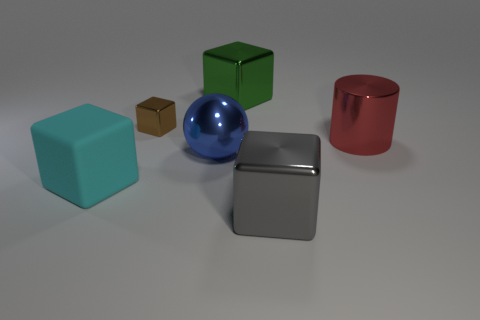Is there a big matte block that is right of the brown shiny object behind the big cyan matte thing?
Make the answer very short. No. Are there an equal number of big cyan rubber objects that are on the left side of the cyan object and tiny brown objects?
Offer a terse response. No. How many big gray metal cubes are behind the large rubber cube behind the shiny thing in front of the rubber block?
Provide a succinct answer. 0. Are there any green metallic cubes that have the same size as the cyan matte thing?
Provide a succinct answer. Yes. Are there fewer green metallic cubes on the right side of the cylinder than small green cylinders?
Provide a short and direct response. No. There is a big cylinder behind the large thing that is in front of the block to the left of the small brown metal block; what is its material?
Your answer should be compact. Metal. Is the number of matte things behind the red cylinder greater than the number of large blue objects to the right of the green metallic cube?
Give a very brief answer. No. What number of shiny objects are either large blue balls or big green things?
Provide a succinct answer. 2. What material is the object on the left side of the brown metal object?
Your answer should be compact. Rubber. What number of objects are metallic cylinders or blocks that are in front of the red thing?
Your answer should be compact. 3. 